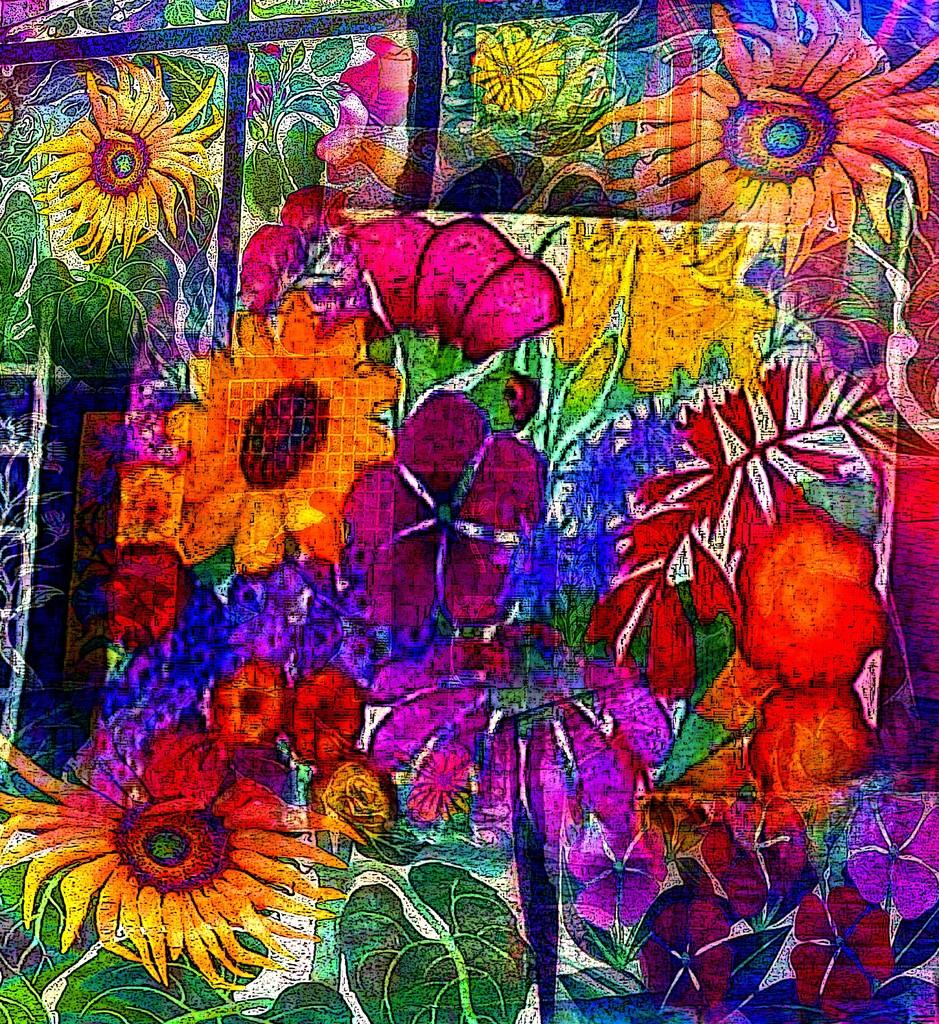What type of living organisms can be seen in the image? There are flowers in the image. Can you describe the variety of colors present in the image? There are objects in different colors in the image. How many visitors can be seen interacting with the flowers in the image? There is no mention of visitors in the image, so it cannot be determined how many visitors might be interacting with the flowers. 